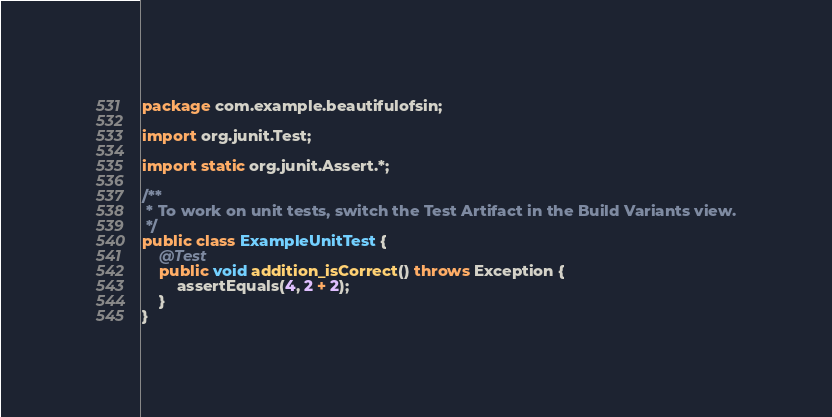Convert code to text. <code><loc_0><loc_0><loc_500><loc_500><_Java_>package com.example.beautifulofsin;

import org.junit.Test;

import static org.junit.Assert.*;

/**
 * To work on unit tests, switch the Test Artifact in the Build Variants view.
 */
public class ExampleUnitTest {
    @Test
    public void addition_isCorrect() throws Exception {
        assertEquals(4, 2 + 2);
    }
}</code> 